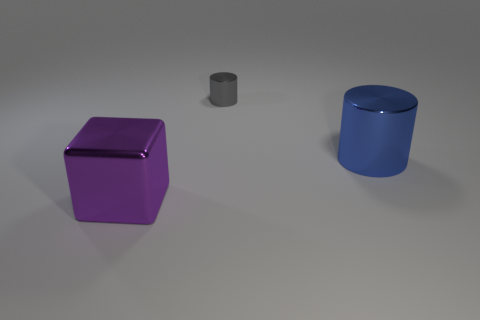Subtract all brown cubes. Subtract all green balls. How many cubes are left? 1 Add 3 small gray cylinders. How many objects exist? 6 Subtract all blocks. How many objects are left? 2 Subtract 0 red balls. How many objects are left? 3 Subtract all green metal balls. Subtract all purple cubes. How many objects are left? 2 Add 1 tiny gray metallic cylinders. How many tiny gray metallic cylinders are left? 2 Add 1 tiny gray metal objects. How many tiny gray metal objects exist? 2 